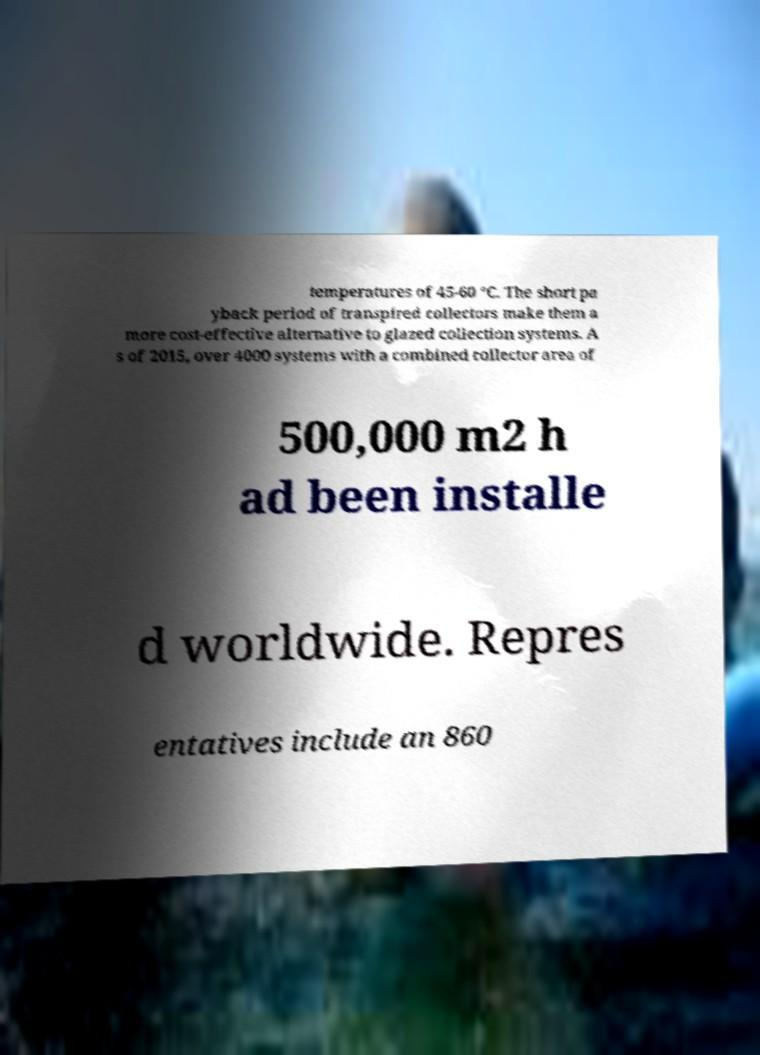Could you extract and type out the text from this image? temperatures of 45-60 °C. The short pa yback period of transpired collectors make them a more cost-effective alternative to glazed collection systems. A s of 2015, over 4000 systems with a combined collector area of 500,000 m2 h ad been installe d worldwide. Repres entatives include an 860 